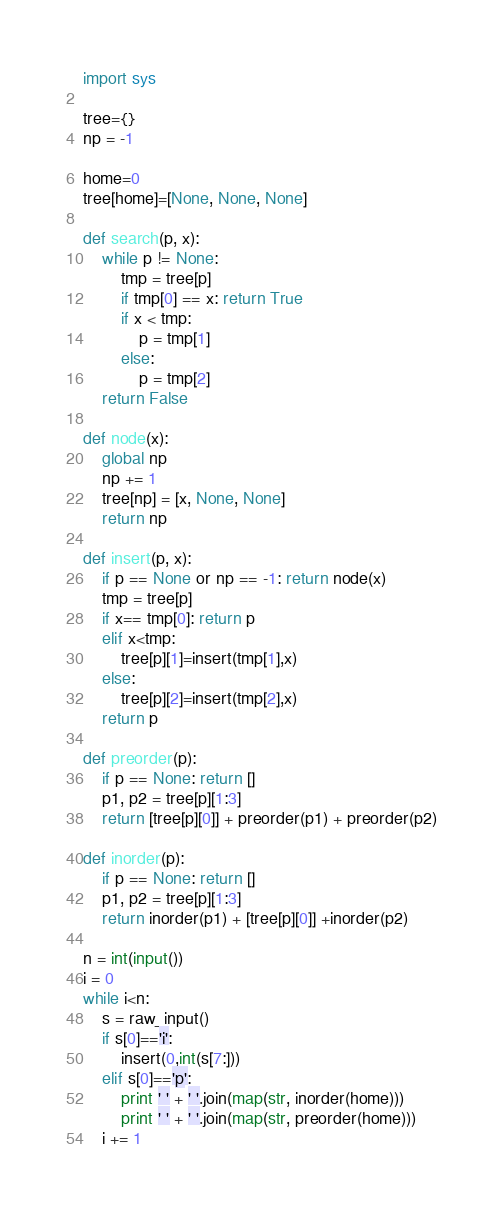<code> <loc_0><loc_0><loc_500><loc_500><_Python_>import sys

tree={}
np = -1

home=0
tree[home]=[None, None, None]

def search(p, x):
    while p != None:
        tmp = tree[p]
        if tmp[0] == x: return True
        if x < tmp:
            p = tmp[1]
        else:
            p = tmp[2]
    return False

def node(x):
    global np
    np += 1
    tree[np] = [x, None, None]
    return np

def insert(p, x):
    if p == None or np == -1: return node(x)
    tmp = tree[p]
    if x== tmp[0]: return p
    elif x<tmp:
        tree[p][1]=insert(tmp[1],x)
    else:
        tree[p][2]=insert(tmp[2],x)
    return p

def preorder(p):
    if p == None: return []
    p1, p2 = tree[p][1:3]
    return [tree[p][0]] + preorder(p1) + preorder(p2)

def inorder(p):
    if p == None: return []
    p1, p2 = tree[p][1:3]
    return inorder(p1) + [tree[p][0]] +inorder(p2)

n = int(input())
i = 0
while i<n:
    s = raw_input()
    if s[0]=='i':
        insert(0,int(s[7:]))
    elif s[0]=='p':
        print ' ' + ' '.join(map(str, inorder(home)))
        print ' ' + ' '.join(map(str, preorder(home)))
    i += 1</code> 